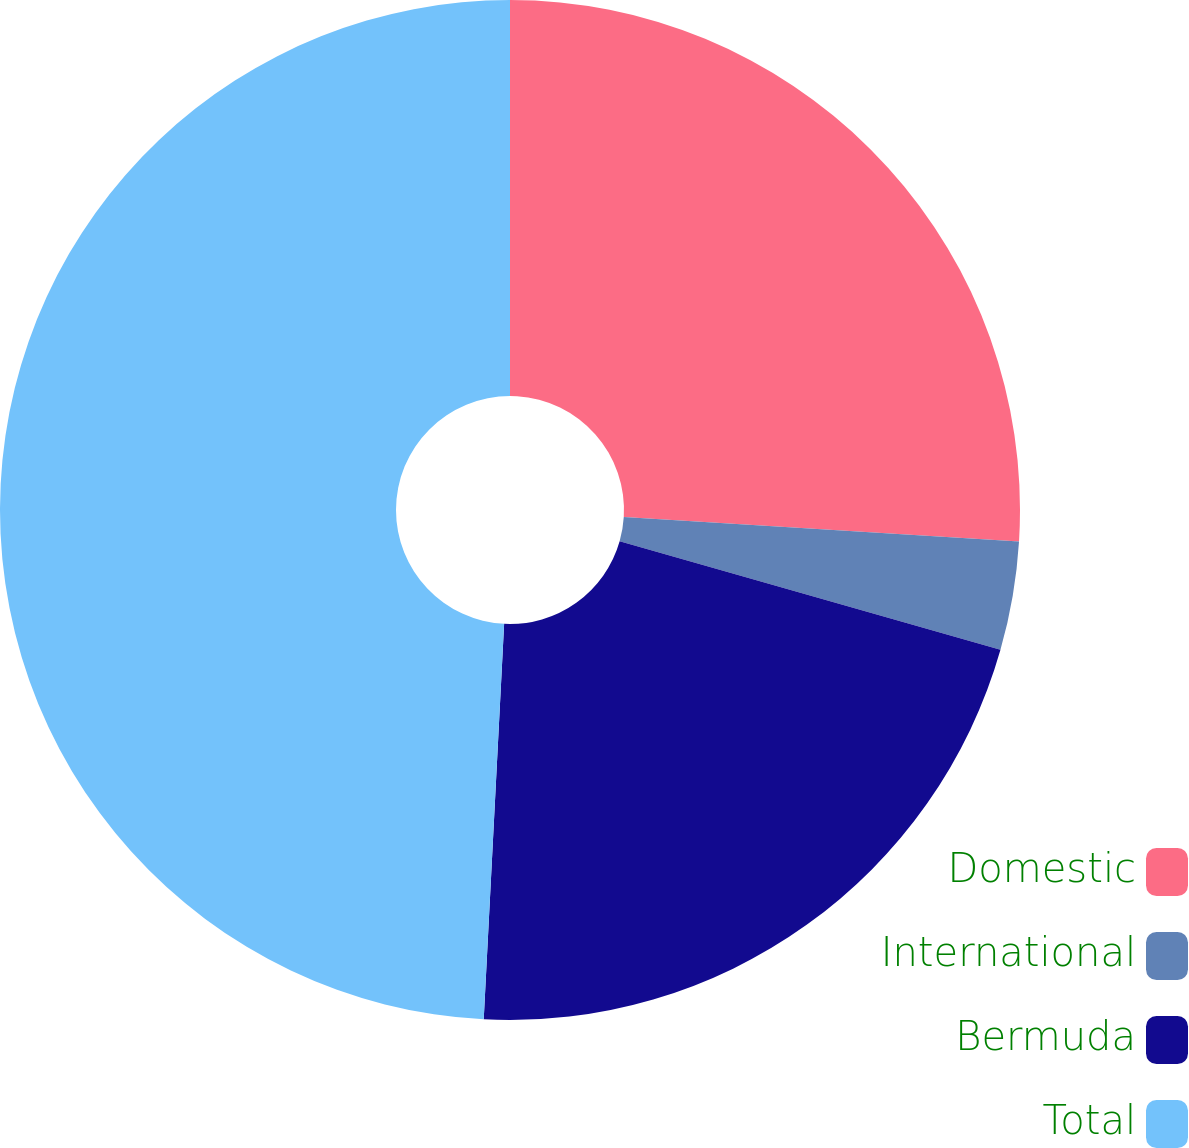Convert chart. <chart><loc_0><loc_0><loc_500><loc_500><pie_chart><fcel>Domestic<fcel>International<fcel>Bermuda<fcel>Total<nl><fcel>25.98%<fcel>3.44%<fcel>21.4%<fcel>49.18%<nl></chart> 